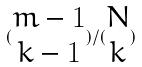Convert formula to latex. <formula><loc_0><loc_0><loc_500><loc_500>( \begin{matrix} m - 1 \\ k - 1 \end{matrix} ) / ( \begin{matrix} N \\ k \end{matrix} )</formula> 